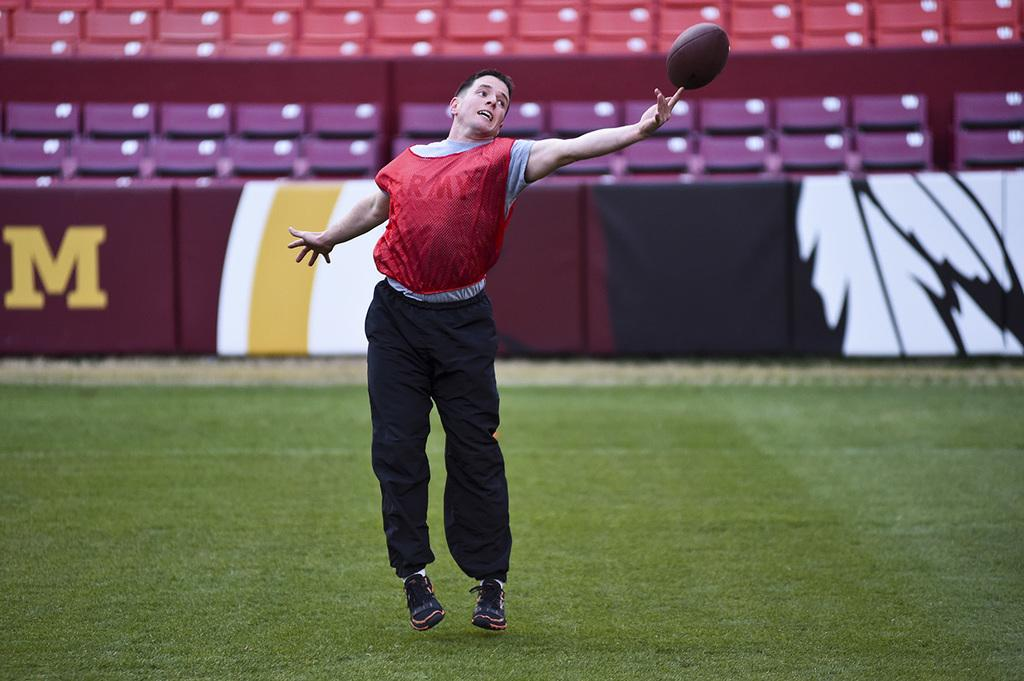What is the main subject in the foreground of the image? There is a person in the foreground of the image. What is the person doing in the image? The person is standing in the image. What object is the person holding in the image? The person is holding a ball in the image. What can be seen in the background of the image? There are boards and chairs in the background of the image. What type of surface is visible at the bottom of the image? There is grass at the bottom of the image. What type of body is visible in the image? There is no body present in the image, only a person holding a ball. What is the relation between the person and the beggar in the image? There is no beggar present in the image, so there is no relation to discuss. 